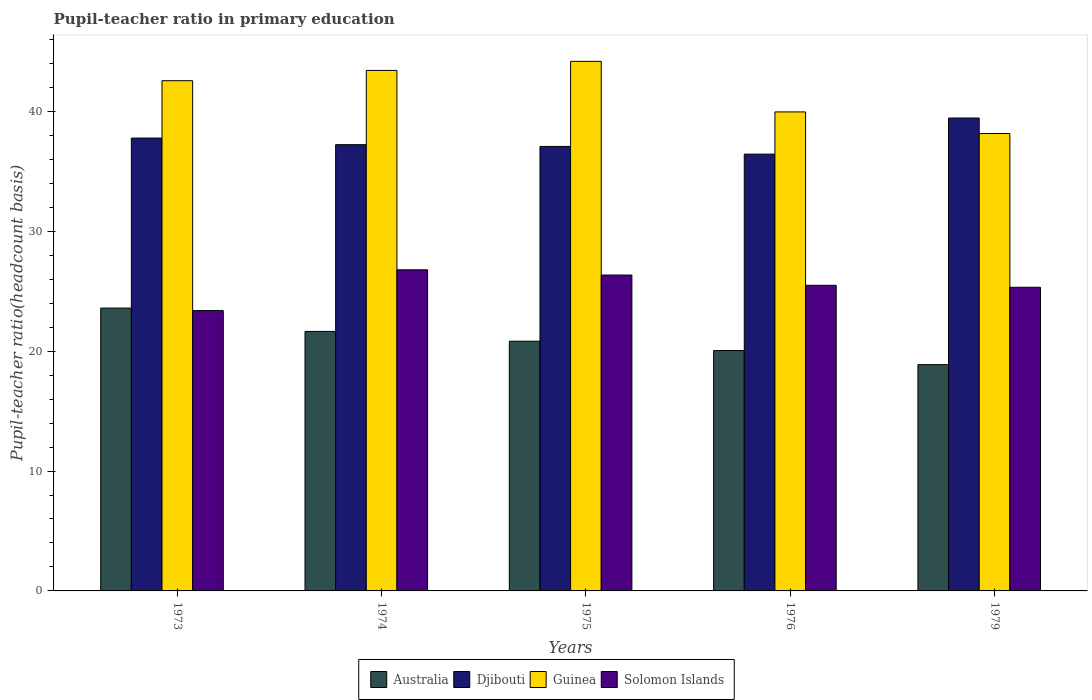How many different coloured bars are there?
Keep it short and to the point. 4. Are the number of bars per tick equal to the number of legend labels?
Your answer should be very brief. Yes. Are the number of bars on each tick of the X-axis equal?
Your answer should be compact. Yes. How many bars are there on the 4th tick from the left?
Your response must be concise. 4. What is the label of the 2nd group of bars from the left?
Your answer should be compact. 1974. In how many cases, is the number of bars for a given year not equal to the number of legend labels?
Your answer should be compact. 0. What is the pupil-teacher ratio in primary education in Guinea in 1974?
Ensure brevity in your answer.  43.42. Across all years, what is the maximum pupil-teacher ratio in primary education in Solomon Islands?
Your answer should be very brief. 26.78. Across all years, what is the minimum pupil-teacher ratio in primary education in Australia?
Your response must be concise. 18.87. In which year was the pupil-teacher ratio in primary education in Guinea maximum?
Your response must be concise. 1975. What is the total pupil-teacher ratio in primary education in Djibouti in the graph?
Offer a very short reply. 187.95. What is the difference between the pupil-teacher ratio in primary education in Djibouti in 1974 and that in 1975?
Ensure brevity in your answer.  0.15. What is the difference between the pupil-teacher ratio in primary education in Australia in 1975 and the pupil-teacher ratio in primary education in Guinea in 1976?
Provide a short and direct response. -19.13. What is the average pupil-teacher ratio in primary education in Australia per year?
Make the answer very short. 21. In the year 1974, what is the difference between the pupil-teacher ratio in primary education in Australia and pupil-teacher ratio in primary education in Guinea?
Offer a very short reply. -21.77. In how many years, is the pupil-teacher ratio in primary education in Australia greater than 26?
Your response must be concise. 0. What is the ratio of the pupil-teacher ratio in primary education in Djibouti in 1973 to that in 1975?
Provide a succinct answer. 1.02. Is the pupil-teacher ratio in primary education in Australia in 1974 less than that in 1979?
Your response must be concise. No. Is the difference between the pupil-teacher ratio in primary education in Australia in 1975 and 1979 greater than the difference between the pupil-teacher ratio in primary education in Guinea in 1975 and 1979?
Make the answer very short. No. What is the difference between the highest and the second highest pupil-teacher ratio in primary education in Australia?
Keep it short and to the point. 1.95. What is the difference between the highest and the lowest pupil-teacher ratio in primary education in Solomon Islands?
Ensure brevity in your answer.  3.4. Is it the case that in every year, the sum of the pupil-teacher ratio in primary education in Australia and pupil-teacher ratio in primary education in Guinea is greater than the sum of pupil-teacher ratio in primary education in Solomon Islands and pupil-teacher ratio in primary education in Djibouti?
Your response must be concise. No. What does the 4th bar from the left in 1976 represents?
Offer a very short reply. Solomon Islands. What does the 1st bar from the right in 1975 represents?
Provide a short and direct response. Solomon Islands. Is it the case that in every year, the sum of the pupil-teacher ratio in primary education in Guinea and pupil-teacher ratio in primary education in Australia is greater than the pupil-teacher ratio in primary education in Solomon Islands?
Your answer should be compact. Yes. How many bars are there?
Your answer should be compact. 20. Are all the bars in the graph horizontal?
Make the answer very short. No. How many years are there in the graph?
Your answer should be compact. 5. What is the difference between two consecutive major ticks on the Y-axis?
Provide a short and direct response. 10. Where does the legend appear in the graph?
Provide a succinct answer. Bottom center. How many legend labels are there?
Ensure brevity in your answer.  4. What is the title of the graph?
Provide a short and direct response. Pupil-teacher ratio in primary education. What is the label or title of the Y-axis?
Provide a succinct answer. Pupil-teacher ratio(headcount basis). What is the Pupil-teacher ratio(headcount basis) in Australia in 1973?
Make the answer very short. 23.59. What is the Pupil-teacher ratio(headcount basis) of Djibouti in 1973?
Offer a terse response. 37.77. What is the Pupil-teacher ratio(headcount basis) in Guinea in 1973?
Keep it short and to the point. 42.56. What is the Pupil-teacher ratio(headcount basis) of Solomon Islands in 1973?
Your answer should be very brief. 23.38. What is the Pupil-teacher ratio(headcount basis) in Australia in 1974?
Offer a very short reply. 21.65. What is the Pupil-teacher ratio(headcount basis) of Djibouti in 1974?
Provide a succinct answer. 37.22. What is the Pupil-teacher ratio(headcount basis) in Guinea in 1974?
Your answer should be very brief. 43.42. What is the Pupil-teacher ratio(headcount basis) of Solomon Islands in 1974?
Your response must be concise. 26.78. What is the Pupil-teacher ratio(headcount basis) in Australia in 1975?
Offer a very short reply. 20.83. What is the Pupil-teacher ratio(headcount basis) in Djibouti in 1975?
Offer a very short reply. 37.08. What is the Pupil-teacher ratio(headcount basis) of Guinea in 1975?
Provide a short and direct response. 44.17. What is the Pupil-teacher ratio(headcount basis) in Solomon Islands in 1975?
Offer a terse response. 26.35. What is the Pupil-teacher ratio(headcount basis) in Australia in 1976?
Offer a terse response. 20.05. What is the Pupil-teacher ratio(headcount basis) in Djibouti in 1976?
Make the answer very short. 36.43. What is the Pupil-teacher ratio(headcount basis) in Guinea in 1976?
Ensure brevity in your answer.  39.95. What is the Pupil-teacher ratio(headcount basis) in Solomon Islands in 1976?
Your answer should be compact. 25.49. What is the Pupil-teacher ratio(headcount basis) of Australia in 1979?
Provide a short and direct response. 18.87. What is the Pupil-teacher ratio(headcount basis) of Djibouti in 1979?
Provide a short and direct response. 39.44. What is the Pupil-teacher ratio(headcount basis) of Guinea in 1979?
Give a very brief answer. 38.15. What is the Pupil-teacher ratio(headcount basis) of Solomon Islands in 1979?
Offer a very short reply. 25.33. Across all years, what is the maximum Pupil-teacher ratio(headcount basis) of Australia?
Your answer should be very brief. 23.59. Across all years, what is the maximum Pupil-teacher ratio(headcount basis) of Djibouti?
Give a very brief answer. 39.44. Across all years, what is the maximum Pupil-teacher ratio(headcount basis) of Guinea?
Give a very brief answer. 44.17. Across all years, what is the maximum Pupil-teacher ratio(headcount basis) in Solomon Islands?
Your response must be concise. 26.78. Across all years, what is the minimum Pupil-teacher ratio(headcount basis) in Australia?
Your answer should be compact. 18.87. Across all years, what is the minimum Pupil-teacher ratio(headcount basis) of Djibouti?
Keep it short and to the point. 36.43. Across all years, what is the minimum Pupil-teacher ratio(headcount basis) in Guinea?
Give a very brief answer. 38.15. Across all years, what is the minimum Pupil-teacher ratio(headcount basis) in Solomon Islands?
Give a very brief answer. 23.38. What is the total Pupil-teacher ratio(headcount basis) of Australia in the graph?
Your answer should be compact. 104.99. What is the total Pupil-teacher ratio(headcount basis) in Djibouti in the graph?
Make the answer very short. 187.95. What is the total Pupil-teacher ratio(headcount basis) of Guinea in the graph?
Offer a very short reply. 208.25. What is the total Pupil-teacher ratio(headcount basis) of Solomon Islands in the graph?
Provide a short and direct response. 127.34. What is the difference between the Pupil-teacher ratio(headcount basis) of Australia in 1973 and that in 1974?
Ensure brevity in your answer.  1.95. What is the difference between the Pupil-teacher ratio(headcount basis) of Djibouti in 1973 and that in 1974?
Provide a succinct answer. 0.55. What is the difference between the Pupil-teacher ratio(headcount basis) of Guinea in 1973 and that in 1974?
Provide a short and direct response. -0.86. What is the difference between the Pupil-teacher ratio(headcount basis) in Solomon Islands in 1973 and that in 1974?
Give a very brief answer. -3.4. What is the difference between the Pupil-teacher ratio(headcount basis) of Australia in 1973 and that in 1975?
Ensure brevity in your answer.  2.76. What is the difference between the Pupil-teacher ratio(headcount basis) in Djibouti in 1973 and that in 1975?
Offer a very short reply. 0.7. What is the difference between the Pupil-teacher ratio(headcount basis) in Guinea in 1973 and that in 1975?
Your answer should be compact. -1.61. What is the difference between the Pupil-teacher ratio(headcount basis) in Solomon Islands in 1973 and that in 1975?
Offer a very short reply. -2.96. What is the difference between the Pupil-teacher ratio(headcount basis) in Australia in 1973 and that in 1976?
Provide a succinct answer. 3.54. What is the difference between the Pupil-teacher ratio(headcount basis) in Djibouti in 1973 and that in 1976?
Your answer should be compact. 1.34. What is the difference between the Pupil-teacher ratio(headcount basis) in Guinea in 1973 and that in 1976?
Ensure brevity in your answer.  2.6. What is the difference between the Pupil-teacher ratio(headcount basis) of Solomon Islands in 1973 and that in 1976?
Ensure brevity in your answer.  -2.11. What is the difference between the Pupil-teacher ratio(headcount basis) of Australia in 1973 and that in 1979?
Your answer should be compact. 4.72. What is the difference between the Pupil-teacher ratio(headcount basis) of Djibouti in 1973 and that in 1979?
Make the answer very short. -1.67. What is the difference between the Pupil-teacher ratio(headcount basis) in Guinea in 1973 and that in 1979?
Your answer should be very brief. 4.41. What is the difference between the Pupil-teacher ratio(headcount basis) of Solomon Islands in 1973 and that in 1979?
Provide a succinct answer. -1.94. What is the difference between the Pupil-teacher ratio(headcount basis) of Australia in 1974 and that in 1975?
Give a very brief answer. 0.82. What is the difference between the Pupil-teacher ratio(headcount basis) of Djibouti in 1974 and that in 1975?
Provide a succinct answer. 0.15. What is the difference between the Pupil-teacher ratio(headcount basis) in Guinea in 1974 and that in 1975?
Make the answer very short. -0.76. What is the difference between the Pupil-teacher ratio(headcount basis) in Solomon Islands in 1974 and that in 1975?
Offer a very short reply. 0.44. What is the difference between the Pupil-teacher ratio(headcount basis) in Australia in 1974 and that in 1976?
Offer a terse response. 1.6. What is the difference between the Pupil-teacher ratio(headcount basis) in Djibouti in 1974 and that in 1976?
Keep it short and to the point. 0.79. What is the difference between the Pupil-teacher ratio(headcount basis) in Guinea in 1974 and that in 1976?
Offer a terse response. 3.46. What is the difference between the Pupil-teacher ratio(headcount basis) of Solomon Islands in 1974 and that in 1976?
Make the answer very short. 1.29. What is the difference between the Pupil-teacher ratio(headcount basis) of Australia in 1974 and that in 1979?
Give a very brief answer. 2.77. What is the difference between the Pupil-teacher ratio(headcount basis) of Djibouti in 1974 and that in 1979?
Keep it short and to the point. -2.22. What is the difference between the Pupil-teacher ratio(headcount basis) in Guinea in 1974 and that in 1979?
Your response must be concise. 5.26. What is the difference between the Pupil-teacher ratio(headcount basis) in Solomon Islands in 1974 and that in 1979?
Provide a short and direct response. 1.46. What is the difference between the Pupil-teacher ratio(headcount basis) of Australia in 1975 and that in 1976?
Your response must be concise. 0.78. What is the difference between the Pupil-teacher ratio(headcount basis) of Djibouti in 1975 and that in 1976?
Provide a succinct answer. 0.64. What is the difference between the Pupil-teacher ratio(headcount basis) in Guinea in 1975 and that in 1976?
Provide a succinct answer. 4.22. What is the difference between the Pupil-teacher ratio(headcount basis) in Solomon Islands in 1975 and that in 1976?
Provide a short and direct response. 0.86. What is the difference between the Pupil-teacher ratio(headcount basis) of Australia in 1975 and that in 1979?
Provide a short and direct response. 1.95. What is the difference between the Pupil-teacher ratio(headcount basis) in Djibouti in 1975 and that in 1979?
Provide a succinct answer. -2.37. What is the difference between the Pupil-teacher ratio(headcount basis) of Guinea in 1975 and that in 1979?
Your response must be concise. 6.02. What is the difference between the Pupil-teacher ratio(headcount basis) in Solomon Islands in 1975 and that in 1979?
Your answer should be compact. 1.02. What is the difference between the Pupil-teacher ratio(headcount basis) in Australia in 1976 and that in 1979?
Your response must be concise. 1.18. What is the difference between the Pupil-teacher ratio(headcount basis) in Djibouti in 1976 and that in 1979?
Give a very brief answer. -3.01. What is the difference between the Pupil-teacher ratio(headcount basis) of Guinea in 1976 and that in 1979?
Give a very brief answer. 1.8. What is the difference between the Pupil-teacher ratio(headcount basis) of Solomon Islands in 1976 and that in 1979?
Your response must be concise. 0.16. What is the difference between the Pupil-teacher ratio(headcount basis) of Australia in 1973 and the Pupil-teacher ratio(headcount basis) of Djibouti in 1974?
Provide a short and direct response. -13.63. What is the difference between the Pupil-teacher ratio(headcount basis) of Australia in 1973 and the Pupil-teacher ratio(headcount basis) of Guinea in 1974?
Ensure brevity in your answer.  -19.82. What is the difference between the Pupil-teacher ratio(headcount basis) of Australia in 1973 and the Pupil-teacher ratio(headcount basis) of Solomon Islands in 1974?
Give a very brief answer. -3.19. What is the difference between the Pupil-teacher ratio(headcount basis) of Djibouti in 1973 and the Pupil-teacher ratio(headcount basis) of Guinea in 1974?
Your answer should be compact. -5.64. What is the difference between the Pupil-teacher ratio(headcount basis) of Djibouti in 1973 and the Pupil-teacher ratio(headcount basis) of Solomon Islands in 1974?
Offer a terse response. 10.99. What is the difference between the Pupil-teacher ratio(headcount basis) in Guinea in 1973 and the Pupil-teacher ratio(headcount basis) in Solomon Islands in 1974?
Provide a short and direct response. 15.77. What is the difference between the Pupil-teacher ratio(headcount basis) of Australia in 1973 and the Pupil-teacher ratio(headcount basis) of Djibouti in 1975?
Offer a terse response. -13.48. What is the difference between the Pupil-teacher ratio(headcount basis) in Australia in 1973 and the Pupil-teacher ratio(headcount basis) in Guinea in 1975?
Your response must be concise. -20.58. What is the difference between the Pupil-teacher ratio(headcount basis) of Australia in 1973 and the Pupil-teacher ratio(headcount basis) of Solomon Islands in 1975?
Offer a very short reply. -2.76. What is the difference between the Pupil-teacher ratio(headcount basis) in Djibouti in 1973 and the Pupil-teacher ratio(headcount basis) in Guinea in 1975?
Provide a succinct answer. -6.4. What is the difference between the Pupil-teacher ratio(headcount basis) of Djibouti in 1973 and the Pupil-teacher ratio(headcount basis) of Solomon Islands in 1975?
Your answer should be compact. 11.42. What is the difference between the Pupil-teacher ratio(headcount basis) of Guinea in 1973 and the Pupil-teacher ratio(headcount basis) of Solomon Islands in 1975?
Provide a succinct answer. 16.21. What is the difference between the Pupil-teacher ratio(headcount basis) in Australia in 1973 and the Pupil-teacher ratio(headcount basis) in Djibouti in 1976?
Ensure brevity in your answer.  -12.84. What is the difference between the Pupil-teacher ratio(headcount basis) in Australia in 1973 and the Pupil-teacher ratio(headcount basis) in Guinea in 1976?
Make the answer very short. -16.36. What is the difference between the Pupil-teacher ratio(headcount basis) of Australia in 1973 and the Pupil-teacher ratio(headcount basis) of Solomon Islands in 1976?
Your answer should be very brief. -1.9. What is the difference between the Pupil-teacher ratio(headcount basis) of Djibouti in 1973 and the Pupil-teacher ratio(headcount basis) of Guinea in 1976?
Make the answer very short. -2.18. What is the difference between the Pupil-teacher ratio(headcount basis) of Djibouti in 1973 and the Pupil-teacher ratio(headcount basis) of Solomon Islands in 1976?
Your response must be concise. 12.28. What is the difference between the Pupil-teacher ratio(headcount basis) of Guinea in 1973 and the Pupil-teacher ratio(headcount basis) of Solomon Islands in 1976?
Provide a short and direct response. 17.07. What is the difference between the Pupil-teacher ratio(headcount basis) of Australia in 1973 and the Pupil-teacher ratio(headcount basis) of Djibouti in 1979?
Make the answer very short. -15.85. What is the difference between the Pupil-teacher ratio(headcount basis) in Australia in 1973 and the Pupil-teacher ratio(headcount basis) in Guinea in 1979?
Make the answer very short. -14.56. What is the difference between the Pupil-teacher ratio(headcount basis) in Australia in 1973 and the Pupil-teacher ratio(headcount basis) in Solomon Islands in 1979?
Ensure brevity in your answer.  -1.73. What is the difference between the Pupil-teacher ratio(headcount basis) in Djibouti in 1973 and the Pupil-teacher ratio(headcount basis) in Guinea in 1979?
Offer a terse response. -0.38. What is the difference between the Pupil-teacher ratio(headcount basis) in Djibouti in 1973 and the Pupil-teacher ratio(headcount basis) in Solomon Islands in 1979?
Provide a succinct answer. 12.45. What is the difference between the Pupil-teacher ratio(headcount basis) in Guinea in 1973 and the Pupil-teacher ratio(headcount basis) in Solomon Islands in 1979?
Keep it short and to the point. 17.23. What is the difference between the Pupil-teacher ratio(headcount basis) in Australia in 1974 and the Pupil-teacher ratio(headcount basis) in Djibouti in 1975?
Your answer should be very brief. -15.43. What is the difference between the Pupil-teacher ratio(headcount basis) in Australia in 1974 and the Pupil-teacher ratio(headcount basis) in Guinea in 1975?
Give a very brief answer. -22.53. What is the difference between the Pupil-teacher ratio(headcount basis) of Australia in 1974 and the Pupil-teacher ratio(headcount basis) of Solomon Islands in 1975?
Make the answer very short. -4.7. What is the difference between the Pupil-teacher ratio(headcount basis) in Djibouti in 1974 and the Pupil-teacher ratio(headcount basis) in Guinea in 1975?
Provide a short and direct response. -6.95. What is the difference between the Pupil-teacher ratio(headcount basis) in Djibouti in 1974 and the Pupil-teacher ratio(headcount basis) in Solomon Islands in 1975?
Provide a succinct answer. 10.87. What is the difference between the Pupil-teacher ratio(headcount basis) of Guinea in 1974 and the Pupil-teacher ratio(headcount basis) of Solomon Islands in 1975?
Keep it short and to the point. 17.07. What is the difference between the Pupil-teacher ratio(headcount basis) in Australia in 1974 and the Pupil-teacher ratio(headcount basis) in Djibouti in 1976?
Your answer should be compact. -14.79. What is the difference between the Pupil-teacher ratio(headcount basis) in Australia in 1974 and the Pupil-teacher ratio(headcount basis) in Guinea in 1976?
Make the answer very short. -18.31. What is the difference between the Pupil-teacher ratio(headcount basis) in Australia in 1974 and the Pupil-teacher ratio(headcount basis) in Solomon Islands in 1976?
Provide a short and direct response. -3.85. What is the difference between the Pupil-teacher ratio(headcount basis) of Djibouti in 1974 and the Pupil-teacher ratio(headcount basis) of Guinea in 1976?
Offer a very short reply. -2.73. What is the difference between the Pupil-teacher ratio(headcount basis) in Djibouti in 1974 and the Pupil-teacher ratio(headcount basis) in Solomon Islands in 1976?
Offer a terse response. 11.73. What is the difference between the Pupil-teacher ratio(headcount basis) in Guinea in 1974 and the Pupil-teacher ratio(headcount basis) in Solomon Islands in 1976?
Give a very brief answer. 17.92. What is the difference between the Pupil-teacher ratio(headcount basis) in Australia in 1974 and the Pupil-teacher ratio(headcount basis) in Djibouti in 1979?
Provide a succinct answer. -17.8. What is the difference between the Pupil-teacher ratio(headcount basis) of Australia in 1974 and the Pupil-teacher ratio(headcount basis) of Guinea in 1979?
Your answer should be very brief. -16.5. What is the difference between the Pupil-teacher ratio(headcount basis) in Australia in 1974 and the Pupil-teacher ratio(headcount basis) in Solomon Islands in 1979?
Your answer should be very brief. -3.68. What is the difference between the Pupil-teacher ratio(headcount basis) of Djibouti in 1974 and the Pupil-teacher ratio(headcount basis) of Guinea in 1979?
Give a very brief answer. -0.93. What is the difference between the Pupil-teacher ratio(headcount basis) of Djibouti in 1974 and the Pupil-teacher ratio(headcount basis) of Solomon Islands in 1979?
Provide a short and direct response. 11.9. What is the difference between the Pupil-teacher ratio(headcount basis) in Guinea in 1974 and the Pupil-teacher ratio(headcount basis) in Solomon Islands in 1979?
Your answer should be very brief. 18.09. What is the difference between the Pupil-teacher ratio(headcount basis) in Australia in 1975 and the Pupil-teacher ratio(headcount basis) in Djibouti in 1976?
Your answer should be compact. -15.6. What is the difference between the Pupil-teacher ratio(headcount basis) of Australia in 1975 and the Pupil-teacher ratio(headcount basis) of Guinea in 1976?
Your response must be concise. -19.13. What is the difference between the Pupil-teacher ratio(headcount basis) of Australia in 1975 and the Pupil-teacher ratio(headcount basis) of Solomon Islands in 1976?
Make the answer very short. -4.66. What is the difference between the Pupil-teacher ratio(headcount basis) in Djibouti in 1975 and the Pupil-teacher ratio(headcount basis) in Guinea in 1976?
Offer a terse response. -2.88. What is the difference between the Pupil-teacher ratio(headcount basis) in Djibouti in 1975 and the Pupil-teacher ratio(headcount basis) in Solomon Islands in 1976?
Keep it short and to the point. 11.58. What is the difference between the Pupil-teacher ratio(headcount basis) in Guinea in 1975 and the Pupil-teacher ratio(headcount basis) in Solomon Islands in 1976?
Give a very brief answer. 18.68. What is the difference between the Pupil-teacher ratio(headcount basis) of Australia in 1975 and the Pupil-teacher ratio(headcount basis) of Djibouti in 1979?
Offer a terse response. -18.62. What is the difference between the Pupil-teacher ratio(headcount basis) in Australia in 1975 and the Pupil-teacher ratio(headcount basis) in Guinea in 1979?
Provide a succinct answer. -17.32. What is the difference between the Pupil-teacher ratio(headcount basis) in Australia in 1975 and the Pupil-teacher ratio(headcount basis) in Solomon Islands in 1979?
Make the answer very short. -4.5. What is the difference between the Pupil-teacher ratio(headcount basis) of Djibouti in 1975 and the Pupil-teacher ratio(headcount basis) of Guinea in 1979?
Offer a very short reply. -1.07. What is the difference between the Pupil-teacher ratio(headcount basis) in Djibouti in 1975 and the Pupil-teacher ratio(headcount basis) in Solomon Islands in 1979?
Your response must be concise. 11.75. What is the difference between the Pupil-teacher ratio(headcount basis) of Guinea in 1975 and the Pupil-teacher ratio(headcount basis) of Solomon Islands in 1979?
Provide a succinct answer. 18.84. What is the difference between the Pupil-teacher ratio(headcount basis) of Australia in 1976 and the Pupil-teacher ratio(headcount basis) of Djibouti in 1979?
Offer a very short reply. -19.39. What is the difference between the Pupil-teacher ratio(headcount basis) of Australia in 1976 and the Pupil-teacher ratio(headcount basis) of Guinea in 1979?
Offer a terse response. -18.1. What is the difference between the Pupil-teacher ratio(headcount basis) of Australia in 1976 and the Pupil-teacher ratio(headcount basis) of Solomon Islands in 1979?
Make the answer very short. -5.28. What is the difference between the Pupil-teacher ratio(headcount basis) of Djibouti in 1976 and the Pupil-teacher ratio(headcount basis) of Guinea in 1979?
Provide a succinct answer. -1.72. What is the difference between the Pupil-teacher ratio(headcount basis) of Djibouti in 1976 and the Pupil-teacher ratio(headcount basis) of Solomon Islands in 1979?
Your answer should be very brief. 11.11. What is the difference between the Pupil-teacher ratio(headcount basis) in Guinea in 1976 and the Pupil-teacher ratio(headcount basis) in Solomon Islands in 1979?
Ensure brevity in your answer.  14.63. What is the average Pupil-teacher ratio(headcount basis) of Australia per year?
Offer a very short reply. 21. What is the average Pupil-teacher ratio(headcount basis) in Djibouti per year?
Provide a short and direct response. 37.59. What is the average Pupil-teacher ratio(headcount basis) in Guinea per year?
Ensure brevity in your answer.  41.65. What is the average Pupil-teacher ratio(headcount basis) of Solomon Islands per year?
Ensure brevity in your answer.  25.47. In the year 1973, what is the difference between the Pupil-teacher ratio(headcount basis) in Australia and Pupil-teacher ratio(headcount basis) in Djibouti?
Your response must be concise. -14.18. In the year 1973, what is the difference between the Pupil-teacher ratio(headcount basis) in Australia and Pupil-teacher ratio(headcount basis) in Guinea?
Ensure brevity in your answer.  -18.97. In the year 1973, what is the difference between the Pupil-teacher ratio(headcount basis) of Australia and Pupil-teacher ratio(headcount basis) of Solomon Islands?
Make the answer very short. 0.21. In the year 1973, what is the difference between the Pupil-teacher ratio(headcount basis) of Djibouti and Pupil-teacher ratio(headcount basis) of Guinea?
Keep it short and to the point. -4.79. In the year 1973, what is the difference between the Pupil-teacher ratio(headcount basis) in Djibouti and Pupil-teacher ratio(headcount basis) in Solomon Islands?
Provide a succinct answer. 14.39. In the year 1973, what is the difference between the Pupil-teacher ratio(headcount basis) in Guinea and Pupil-teacher ratio(headcount basis) in Solomon Islands?
Offer a terse response. 19.17. In the year 1974, what is the difference between the Pupil-teacher ratio(headcount basis) of Australia and Pupil-teacher ratio(headcount basis) of Djibouti?
Provide a short and direct response. -15.58. In the year 1974, what is the difference between the Pupil-teacher ratio(headcount basis) of Australia and Pupil-teacher ratio(headcount basis) of Guinea?
Your answer should be compact. -21.77. In the year 1974, what is the difference between the Pupil-teacher ratio(headcount basis) of Australia and Pupil-teacher ratio(headcount basis) of Solomon Islands?
Provide a short and direct response. -5.14. In the year 1974, what is the difference between the Pupil-teacher ratio(headcount basis) of Djibouti and Pupil-teacher ratio(headcount basis) of Guinea?
Ensure brevity in your answer.  -6.19. In the year 1974, what is the difference between the Pupil-teacher ratio(headcount basis) of Djibouti and Pupil-teacher ratio(headcount basis) of Solomon Islands?
Provide a succinct answer. 10.44. In the year 1974, what is the difference between the Pupil-teacher ratio(headcount basis) of Guinea and Pupil-teacher ratio(headcount basis) of Solomon Islands?
Ensure brevity in your answer.  16.63. In the year 1975, what is the difference between the Pupil-teacher ratio(headcount basis) of Australia and Pupil-teacher ratio(headcount basis) of Djibouti?
Your answer should be compact. -16.25. In the year 1975, what is the difference between the Pupil-teacher ratio(headcount basis) of Australia and Pupil-teacher ratio(headcount basis) of Guinea?
Give a very brief answer. -23.34. In the year 1975, what is the difference between the Pupil-teacher ratio(headcount basis) of Australia and Pupil-teacher ratio(headcount basis) of Solomon Islands?
Keep it short and to the point. -5.52. In the year 1975, what is the difference between the Pupil-teacher ratio(headcount basis) of Djibouti and Pupil-teacher ratio(headcount basis) of Guinea?
Ensure brevity in your answer.  -7.1. In the year 1975, what is the difference between the Pupil-teacher ratio(headcount basis) in Djibouti and Pupil-teacher ratio(headcount basis) in Solomon Islands?
Provide a short and direct response. 10.73. In the year 1975, what is the difference between the Pupil-teacher ratio(headcount basis) in Guinea and Pupil-teacher ratio(headcount basis) in Solomon Islands?
Your response must be concise. 17.82. In the year 1976, what is the difference between the Pupil-teacher ratio(headcount basis) of Australia and Pupil-teacher ratio(headcount basis) of Djibouti?
Your answer should be very brief. -16.38. In the year 1976, what is the difference between the Pupil-teacher ratio(headcount basis) of Australia and Pupil-teacher ratio(headcount basis) of Guinea?
Your answer should be very brief. -19.9. In the year 1976, what is the difference between the Pupil-teacher ratio(headcount basis) of Australia and Pupil-teacher ratio(headcount basis) of Solomon Islands?
Provide a succinct answer. -5.44. In the year 1976, what is the difference between the Pupil-teacher ratio(headcount basis) in Djibouti and Pupil-teacher ratio(headcount basis) in Guinea?
Provide a succinct answer. -3.52. In the year 1976, what is the difference between the Pupil-teacher ratio(headcount basis) of Djibouti and Pupil-teacher ratio(headcount basis) of Solomon Islands?
Keep it short and to the point. 10.94. In the year 1976, what is the difference between the Pupil-teacher ratio(headcount basis) of Guinea and Pupil-teacher ratio(headcount basis) of Solomon Islands?
Your answer should be compact. 14.46. In the year 1979, what is the difference between the Pupil-teacher ratio(headcount basis) of Australia and Pupil-teacher ratio(headcount basis) of Djibouti?
Your answer should be very brief. -20.57. In the year 1979, what is the difference between the Pupil-teacher ratio(headcount basis) in Australia and Pupil-teacher ratio(headcount basis) in Guinea?
Offer a very short reply. -19.28. In the year 1979, what is the difference between the Pupil-teacher ratio(headcount basis) of Australia and Pupil-teacher ratio(headcount basis) of Solomon Islands?
Your answer should be compact. -6.45. In the year 1979, what is the difference between the Pupil-teacher ratio(headcount basis) in Djibouti and Pupil-teacher ratio(headcount basis) in Guinea?
Offer a very short reply. 1.29. In the year 1979, what is the difference between the Pupil-teacher ratio(headcount basis) of Djibouti and Pupil-teacher ratio(headcount basis) of Solomon Islands?
Your answer should be very brief. 14.12. In the year 1979, what is the difference between the Pupil-teacher ratio(headcount basis) of Guinea and Pupil-teacher ratio(headcount basis) of Solomon Islands?
Your answer should be very brief. 12.82. What is the ratio of the Pupil-teacher ratio(headcount basis) of Australia in 1973 to that in 1974?
Your answer should be compact. 1.09. What is the ratio of the Pupil-teacher ratio(headcount basis) in Djibouti in 1973 to that in 1974?
Your answer should be very brief. 1.01. What is the ratio of the Pupil-teacher ratio(headcount basis) of Guinea in 1973 to that in 1974?
Provide a short and direct response. 0.98. What is the ratio of the Pupil-teacher ratio(headcount basis) in Solomon Islands in 1973 to that in 1974?
Make the answer very short. 0.87. What is the ratio of the Pupil-teacher ratio(headcount basis) of Australia in 1973 to that in 1975?
Make the answer very short. 1.13. What is the ratio of the Pupil-teacher ratio(headcount basis) in Djibouti in 1973 to that in 1975?
Your response must be concise. 1.02. What is the ratio of the Pupil-teacher ratio(headcount basis) of Guinea in 1973 to that in 1975?
Give a very brief answer. 0.96. What is the ratio of the Pupil-teacher ratio(headcount basis) in Solomon Islands in 1973 to that in 1975?
Provide a succinct answer. 0.89. What is the ratio of the Pupil-teacher ratio(headcount basis) in Australia in 1973 to that in 1976?
Your answer should be very brief. 1.18. What is the ratio of the Pupil-teacher ratio(headcount basis) of Djibouti in 1973 to that in 1976?
Your answer should be very brief. 1.04. What is the ratio of the Pupil-teacher ratio(headcount basis) of Guinea in 1973 to that in 1976?
Ensure brevity in your answer.  1.07. What is the ratio of the Pupil-teacher ratio(headcount basis) of Solomon Islands in 1973 to that in 1976?
Offer a terse response. 0.92. What is the ratio of the Pupil-teacher ratio(headcount basis) in Australia in 1973 to that in 1979?
Ensure brevity in your answer.  1.25. What is the ratio of the Pupil-teacher ratio(headcount basis) of Djibouti in 1973 to that in 1979?
Give a very brief answer. 0.96. What is the ratio of the Pupil-teacher ratio(headcount basis) of Guinea in 1973 to that in 1979?
Your answer should be compact. 1.12. What is the ratio of the Pupil-teacher ratio(headcount basis) of Solomon Islands in 1973 to that in 1979?
Your answer should be compact. 0.92. What is the ratio of the Pupil-teacher ratio(headcount basis) in Australia in 1974 to that in 1975?
Offer a very short reply. 1.04. What is the ratio of the Pupil-teacher ratio(headcount basis) in Guinea in 1974 to that in 1975?
Provide a short and direct response. 0.98. What is the ratio of the Pupil-teacher ratio(headcount basis) in Solomon Islands in 1974 to that in 1975?
Your response must be concise. 1.02. What is the ratio of the Pupil-teacher ratio(headcount basis) in Australia in 1974 to that in 1976?
Keep it short and to the point. 1.08. What is the ratio of the Pupil-teacher ratio(headcount basis) in Djibouti in 1974 to that in 1976?
Provide a short and direct response. 1.02. What is the ratio of the Pupil-teacher ratio(headcount basis) in Guinea in 1974 to that in 1976?
Make the answer very short. 1.09. What is the ratio of the Pupil-teacher ratio(headcount basis) of Solomon Islands in 1974 to that in 1976?
Make the answer very short. 1.05. What is the ratio of the Pupil-teacher ratio(headcount basis) in Australia in 1974 to that in 1979?
Offer a very short reply. 1.15. What is the ratio of the Pupil-teacher ratio(headcount basis) in Djibouti in 1974 to that in 1979?
Give a very brief answer. 0.94. What is the ratio of the Pupil-teacher ratio(headcount basis) of Guinea in 1974 to that in 1979?
Provide a succinct answer. 1.14. What is the ratio of the Pupil-teacher ratio(headcount basis) in Solomon Islands in 1974 to that in 1979?
Your answer should be very brief. 1.06. What is the ratio of the Pupil-teacher ratio(headcount basis) of Australia in 1975 to that in 1976?
Your answer should be very brief. 1.04. What is the ratio of the Pupil-teacher ratio(headcount basis) of Djibouti in 1975 to that in 1976?
Provide a short and direct response. 1.02. What is the ratio of the Pupil-teacher ratio(headcount basis) of Guinea in 1975 to that in 1976?
Make the answer very short. 1.11. What is the ratio of the Pupil-teacher ratio(headcount basis) in Solomon Islands in 1975 to that in 1976?
Make the answer very short. 1.03. What is the ratio of the Pupil-teacher ratio(headcount basis) in Australia in 1975 to that in 1979?
Give a very brief answer. 1.1. What is the ratio of the Pupil-teacher ratio(headcount basis) of Guinea in 1975 to that in 1979?
Your answer should be very brief. 1.16. What is the ratio of the Pupil-teacher ratio(headcount basis) in Solomon Islands in 1975 to that in 1979?
Your response must be concise. 1.04. What is the ratio of the Pupil-teacher ratio(headcount basis) in Australia in 1976 to that in 1979?
Give a very brief answer. 1.06. What is the ratio of the Pupil-teacher ratio(headcount basis) of Djibouti in 1976 to that in 1979?
Offer a very short reply. 0.92. What is the ratio of the Pupil-teacher ratio(headcount basis) in Guinea in 1976 to that in 1979?
Provide a short and direct response. 1.05. What is the difference between the highest and the second highest Pupil-teacher ratio(headcount basis) of Australia?
Your answer should be very brief. 1.95. What is the difference between the highest and the second highest Pupil-teacher ratio(headcount basis) in Djibouti?
Keep it short and to the point. 1.67. What is the difference between the highest and the second highest Pupil-teacher ratio(headcount basis) in Guinea?
Give a very brief answer. 0.76. What is the difference between the highest and the second highest Pupil-teacher ratio(headcount basis) of Solomon Islands?
Make the answer very short. 0.44. What is the difference between the highest and the lowest Pupil-teacher ratio(headcount basis) in Australia?
Your response must be concise. 4.72. What is the difference between the highest and the lowest Pupil-teacher ratio(headcount basis) in Djibouti?
Keep it short and to the point. 3.01. What is the difference between the highest and the lowest Pupil-teacher ratio(headcount basis) in Guinea?
Provide a short and direct response. 6.02. What is the difference between the highest and the lowest Pupil-teacher ratio(headcount basis) in Solomon Islands?
Make the answer very short. 3.4. 